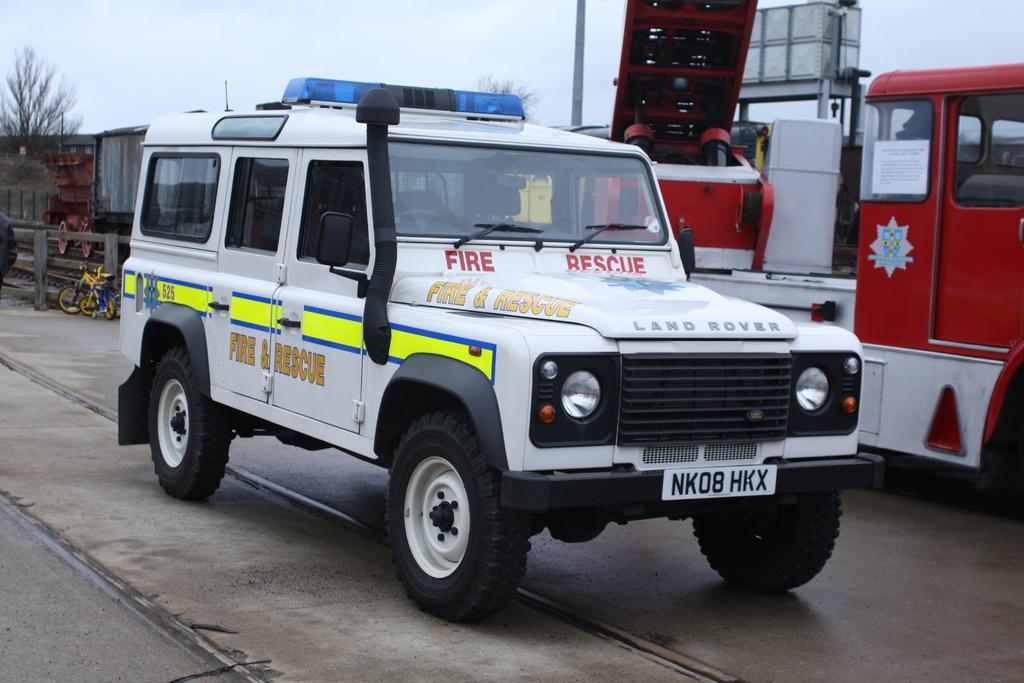Can you describe this image briefly? In this image we can see group of vehicles with text parked on the ground. To the left side of the image we can see a person, bicycles, building and a fence. In the background, we can see a group of trees, pole, container placed on the stand and the sky. 